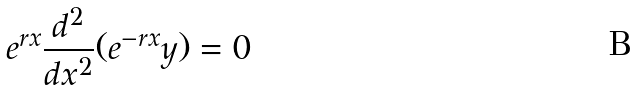Convert formula to latex. <formula><loc_0><loc_0><loc_500><loc_500>e ^ { r x } \frac { d ^ { 2 } } { d x ^ { 2 } } ( e ^ { - r x } y ) = 0</formula> 